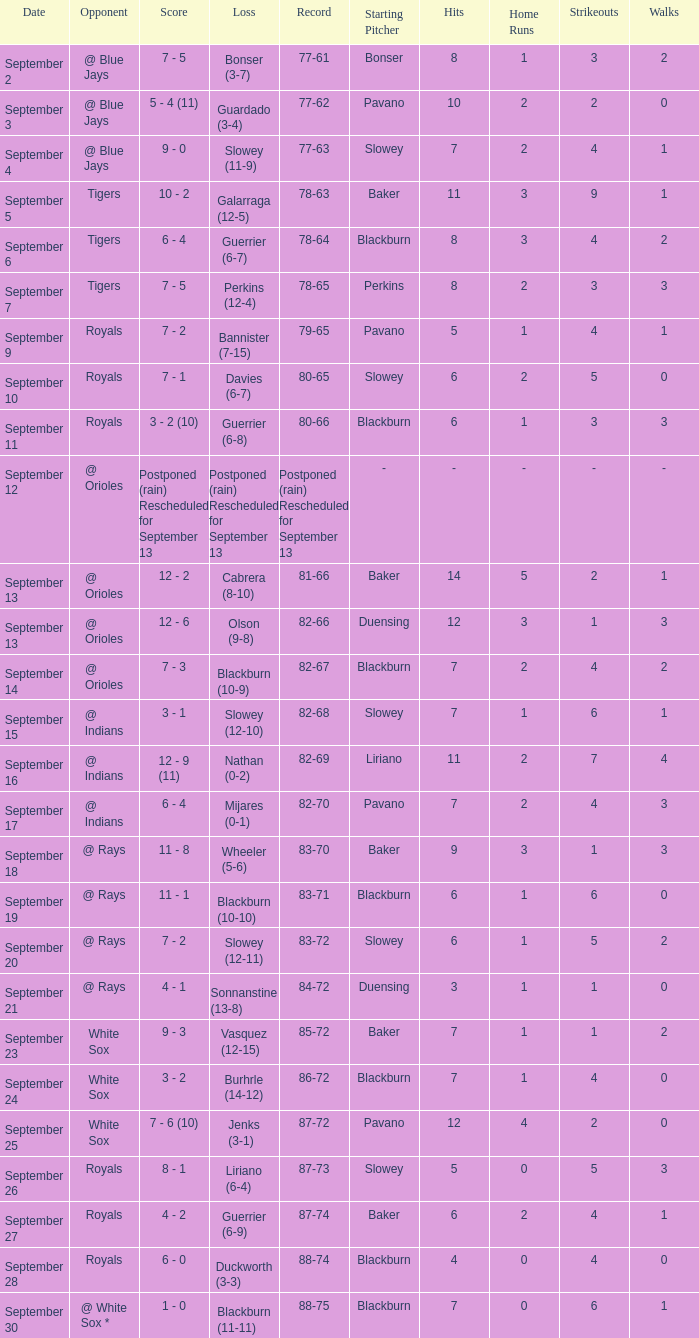What opponnent has a record of 82-68? @ Indians. Can you give me this table as a dict? {'header': ['Date', 'Opponent', 'Score', 'Loss', 'Record', 'Starting Pitcher', 'Hits', 'Home Runs', 'Strikeouts', 'Walks'], 'rows': [['September 2', '@ Blue Jays', '7 - 5', 'Bonser (3-7)', '77-61', 'Bonser', '8', '1', '3', '2'], ['September 3', '@ Blue Jays', '5 - 4 (11)', 'Guardado (3-4)', '77-62', 'Pavano', '10', '2', '2', '0'], ['September 4', '@ Blue Jays', '9 - 0', 'Slowey (11-9)', '77-63', 'Slowey', '7', '2', '4', '1'], ['September 5', 'Tigers', '10 - 2', 'Galarraga (12-5)', '78-63', 'Baker', '11', '3', '9', '1'], ['September 6', 'Tigers', '6 - 4', 'Guerrier (6-7)', '78-64', 'Blackburn', '8', '3', '4', '2'], ['September 7', 'Tigers', '7 - 5', 'Perkins (12-4)', '78-65', 'Perkins', '8', '2', '3', '3'], ['September 9', 'Royals', '7 - 2', 'Bannister (7-15)', '79-65', 'Pavano', '5', '1', '4', '1'], ['September 10', 'Royals', '7 - 1', 'Davies (6-7)', '80-65', 'Slowey', '6', '2', '5', '0'], ['September 11', 'Royals', '3 - 2 (10)', 'Guerrier (6-8)', '80-66', 'Blackburn', '6', '1', '3', '3'], ['September 12', '@ Orioles', 'Postponed (rain) Rescheduled for September 13', 'Postponed (rain) Rescheduled for September 13', 'Postponed (rain) Rescheduled for September 13', '-', '-', '-', '-', '-'], ['September 13', '@ Orioles', '12 - 2', 'Cabrera (8-10)', '81-66', 'Baker', '14', '5', '2', '1'], ['September 13', '@ Orioles', '12 - 6', 'Olson (9-8)', '82-66', 'Duensing', '12', '3', '1', '3'], ['September 14', '@ Orioles', '7 - 3', 'Blackburn (10-9)', '82-67', 'Blackburn', '7', '2', '4', '2'], ['September 15', '@ Indians', '3 - 1', 'Slowey (12-10)', '82-68', 'Slowey', '7', '1', '6', '1'], ['September 16', '@ Indians', '12 - 9 (11)', 'Nathan (0-2)', '82-69', 'Liriano', '11', '2', '7', '4'], ['September 17', '@ Indians', '6 - 4', 'Mijares (0-1)', '82-70', 'Pavano', '7', '2', '4', '3'], ['September 18', '@ Rays', '11 - 8', 'Wheeler (5-6)', '83-70', 'Baker', '9', '3', '1', '3'], ['September 19', '@ Rays', '11 - 1', 'Blackburn (10-10)', '83-71', 'Blackburn', '6', '1', '6', '0'], ['September 20', '@ Rays', '7 - 2', 'Slowey (12-11)', '83-72', 'Slowey', '6', '1', '5', '2'], ['September 21', '@ Rays', '4 - 1', 'Sonnanstine (13-8)', '84-72', 'Duensing', '3', '1', '1', '0'], ['September 23', 'White Sox', '9 - 3', 'Vasquez (12-15)', '85-72', 'Baker', '7', '1', '1', '2'], ['September 24', 'White Sox', '3 - 2', 'Burhrle (14-12)', '86-72', 'Blackburn', '7', '1', '4', '0'], ['September 25', 'White Sox', '7 - 6 (10)', 'Jenks (3-1)', '87-72', 'Pavano', '12', '4', '2', '0'], ['September 26', 'Royals', '8 - 1', 'Liriano (6-4)', '87-73', 'Slowey', '5', '0', '5', '3'], ['September 27', 'Royals', '4 - 2', 'Guerrier (6-9)', '87-74', 'Baker', '6', '2', '4', '1'], ['September 28', 'Royals', '6 - 0', 'Duckworth (3-3)', '88-74', 'Blackburn', '4', '0', '4', '0'], ['September 30', '@ White Sox *', '1 - 0', 'Blackburn (11-11)', '88-75', 'Blackburn', '7', '0', '6', '1']]} 